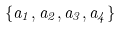Convert formula to latex. <formula><loc_0><loc_0><loc_500><loc_500>\{ a _ { 1 } , a _ { 2 } , a _ { 3 } , a _ { 4 } \}</formula> 